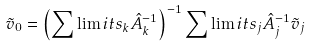<formula> <loc_0><loc_0><loc_500><loc_500>\tilde { v } _ { 0 } = \left ( \sum \lim i t s _ { k } \hat { A } _ { k } ^ { - 1 } \right ) ^ { - 1 } \sum \lim i t s _ { j } \hat { A } _ { j } ^ { - 1 } \tilde { v } _ { j }</formula> 